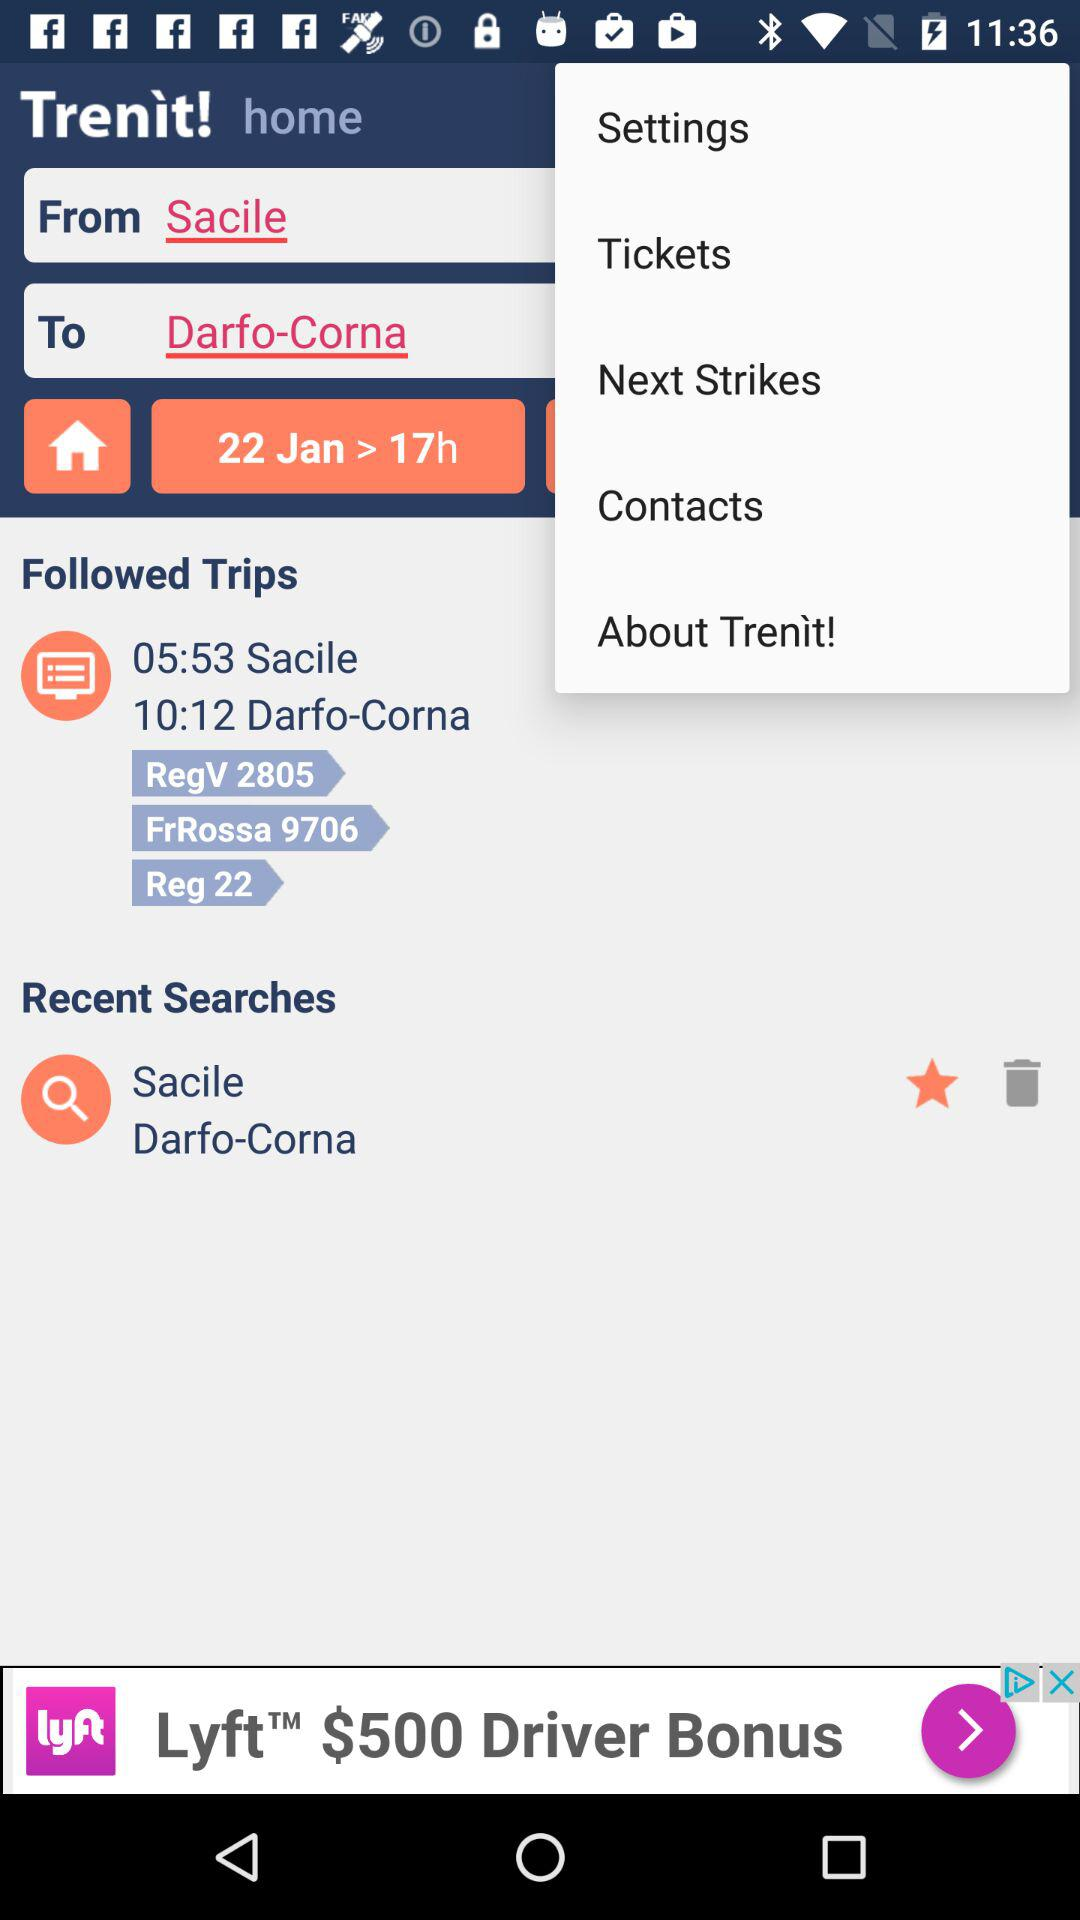What's the arrival destination? The arrival destination is Darfo-Corna. 